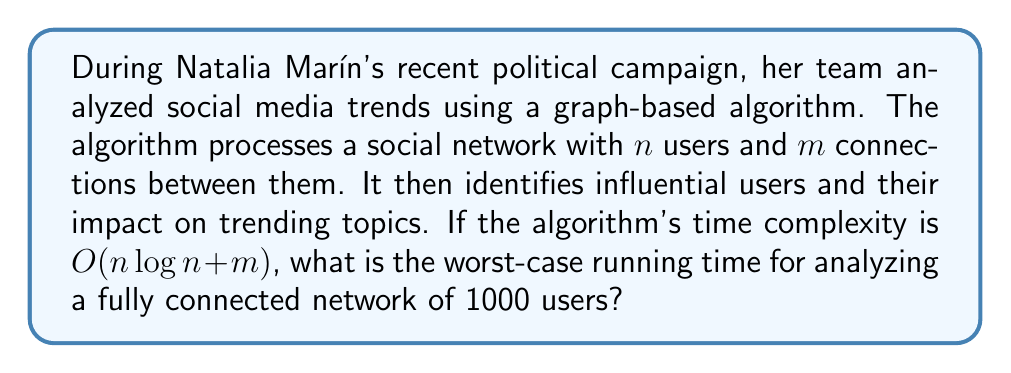Can you answer this question? Let's approach this step-by-step:

1) In a fully connected network, every user is connected to every other user. This means:
   - Number of users, $n = 1000$
   - Number of connections, $m = \frac{n(n-1)}{2}$

2) Calculate $m$:
   $$m = \frac{1000(1000-1)}{2} = \frac{1000 \times 999}{2} = 499,500$$

3) The algorithm's time complexity is $O(n \log n + m)$. Let's calculate each part:

   a) $n \log n$ part:
      $$1000 \log 1000 \approx 1000 \times 3 = 3000$$

   b) $m$ part:
      $$499,500$$

4) The total complexity is the sum of these parts:
   $$3000 + 499,500 = 502,500$$

5) In Big O notation, we ignore constants and lower-order terms. The dominant term here is $m$, which is $O(n^2)$ for a fully connected graph.

Therefore, the worst-case running time for this fully connected network is $O(n^2)$.
Answer: $O(n^2)$, or more precisely, $O(499,500) \approx O(500,000)$ operations. 